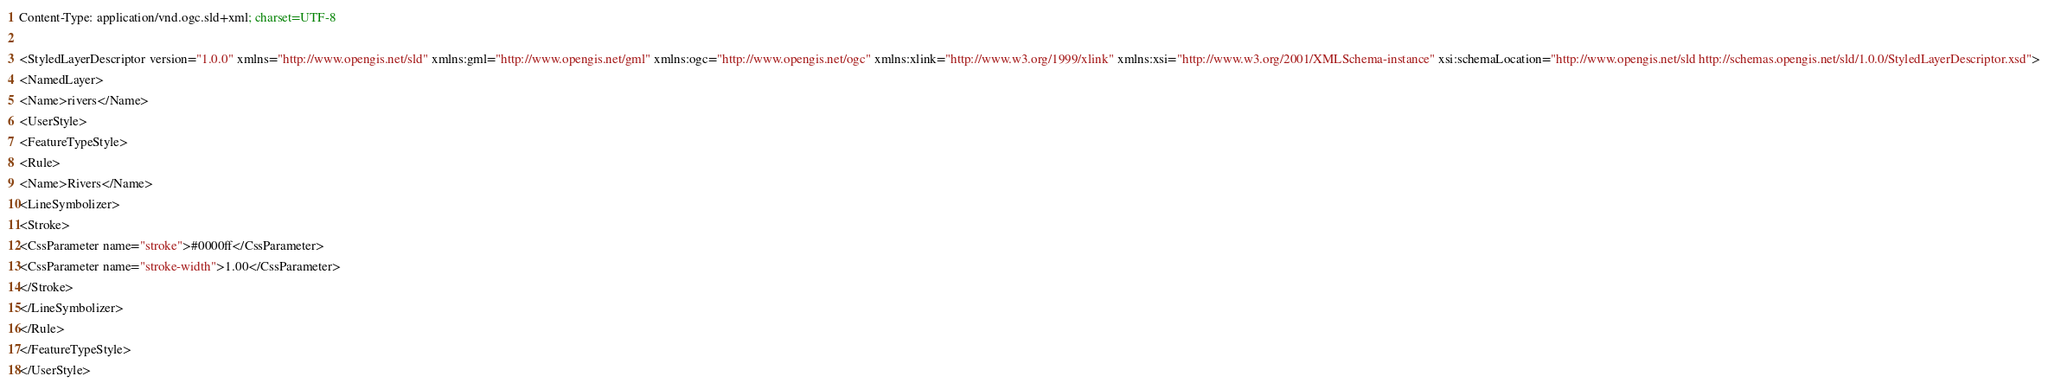<code> <loc_0><loc_0><loc_500><loc_500><_Scheme_>Content-Type: application/vnd.ogc.sld+xml; charset=UTF-8

<StyledLayerDescriptor version="1.0.0" xmlns="http://www.opengis.net/sld" xmlns:gml="http://www.opengis.net/gml" xmlns:ogc="http://www.opengis.net/ogc" xmlns:xlink="http://www.w3.org/1999/xlink" xmlns:xsi="http://www.w3.org/2001/XMLSchema-instance" xsi:schemaLocation="http://www.opengis.net/sld http://schemas.opengis.net/sld/1.0.0/StyledLayerDescriptor.xsd">
<NamedLayer>
<Name>rivers</Name>
<UserStyle>
<FeatureTypeStyle>
<Rule>
<Name>Rivers</Name>
<LineSymbolizer>
<Stroke>
<CssParameter name="stroke">#0000ff</CssParameter>
<CssParameter name="stroke-width">1.00</CssParameter>
</Stroke>
</LineSymbolizer>
</Rule>
</FeatureTypeStyle>
</UserStyle></code> 